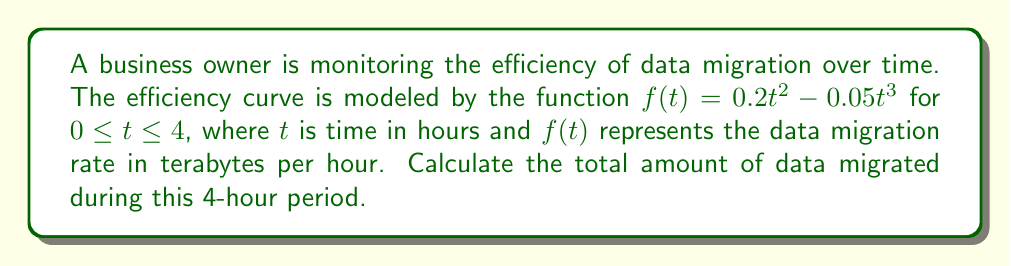Could you help me with this problem? To find the total amount of data migrated, we need to calculate the area under the curve $f(t)$ from $t=0$ to $t=4$. This can be done using definite integration:

1) Set up the definite integral:
   $$\int_0^4 (0.2t^2 - 0.05t^3) dt$$

2) Integrate the function:
   $$\left[ 0.2 \cdot \frac{t^3}{3} - 0.05 \cdot \frac{t^4}{4} \right]_0^4$$

3) Evaluate the integral at the upper and lower bounds:
   $$\left( 0.2 \cdot \frac{4^3}{3} - 0.05 \cdot \frac{4^4}{4} \right) - \left( 0.2 \cdot \frac{0^3}{3} - 0.05 \cdot \frac{0^4}{4} \right)$$

4) Simplify:
   $$\left( 0.2 \cdot \frac{64}{3} - 0.05 \cdot 64 \right) - 0$$
   $$\frac{64}{3} \cdot 0.2 - 64 \cdot 0.05$$
   $$\frac{12.8}{3} - 3.2$$
   $$4.267 - 3.2$$
   $$1.067$$

Therefore, the total amount of data migrated during the 4-hour period is approximately 1.067 terabytes.
Answer: 1.067 terabytes 